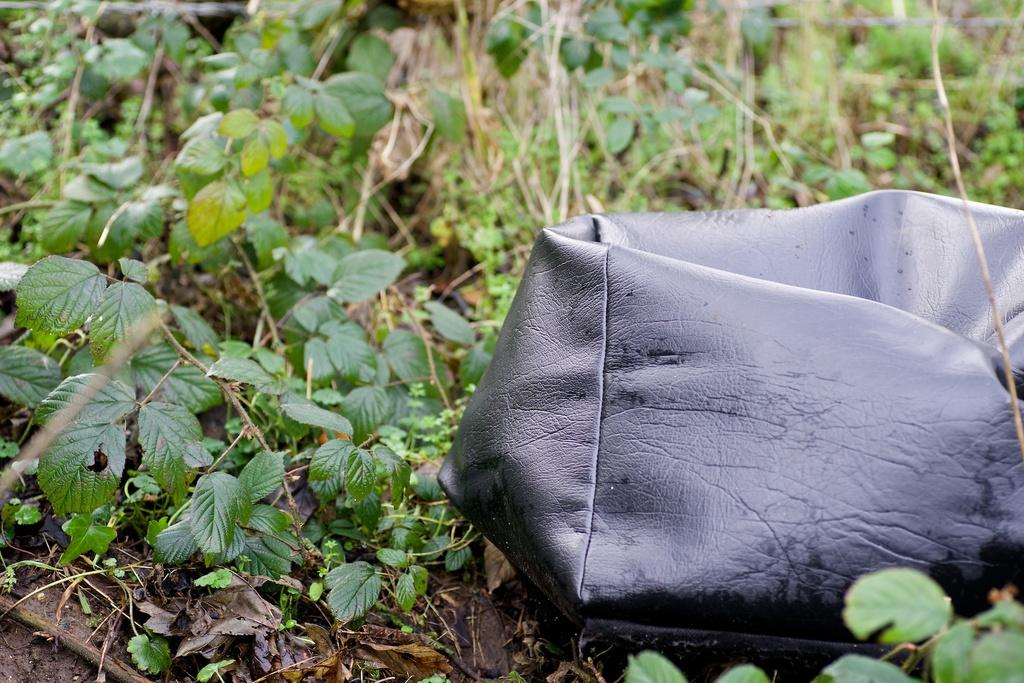What is located on the ground in the image? There is an object on the ground in the image. What type of living organisms can be seen in the image? Plants are visible in the image. What type of crown is the maid wearing in the image? There is no maid or crown present in the image. 